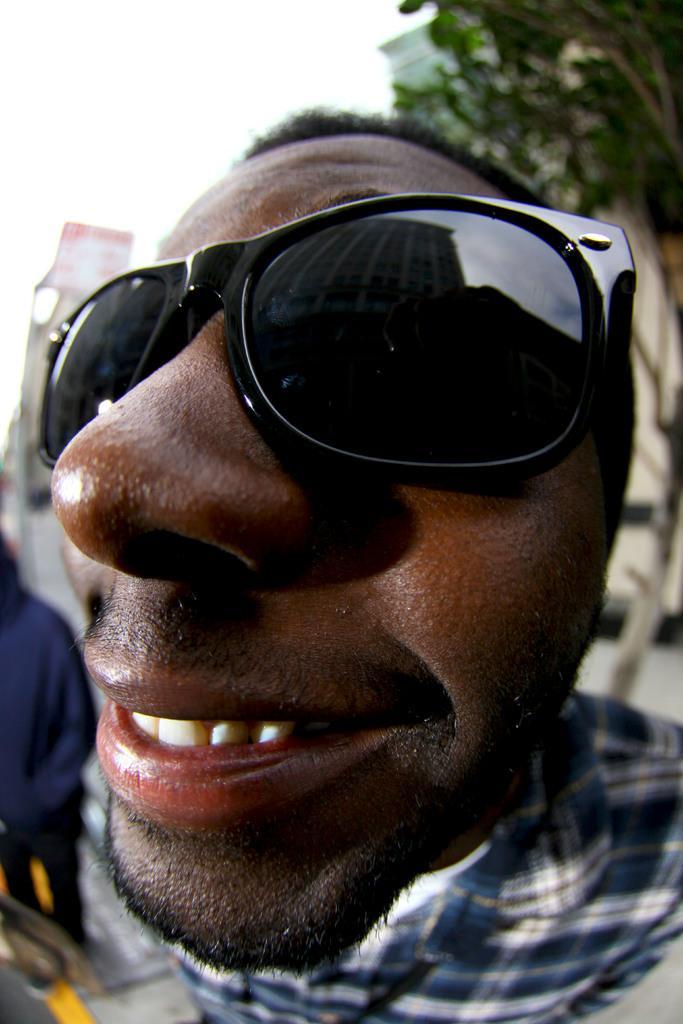Please provide a concise description of this image. In this picture we can see a man wore goggles and smiling and in the background we can see a tree, buildings, some people. 